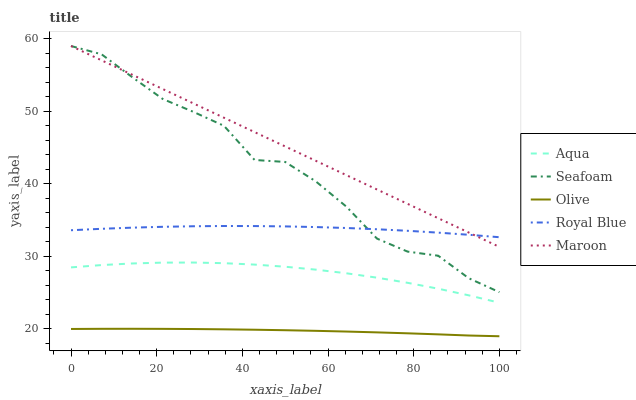Does Olive have the minimum area under the curve?
Answer yes or no. Yes. Does Maroon have the maximum area under the curve?
Answer yes or no. Yes. Does Royal Blue have the minimum area under the curve?
Answer yes or no. No. Does Royal Blue have the maximum area under the curve?
Answer yes or no. No. Is Maroon the smoothest?
Answer yes or no. Yes. Is Seafoam the roughest?
Answer yes or no. Yes. Is Royal Blue the smoothest?
Answer yes or no. No. Is Royal Blue the roughest?
Answer yes or no. No. Does Olive have the lowest value?
Answer yes or no. Yes. Does Aqua have the lowest value?
Answer yes or no. No. Does Maroon have the highest value?
Answer yes or no. Yes. Does Royal Blue have the highest value?
Answer yes or no. No. Is Aqua less than Royal Blue?
Answer yes or no. Yes. Is Seafoam greater than Olive?
Answer yes or no. Yes. Does Royal Blue intersect Maroon?
Answer yes or no. Yes. Is Royal Blue less than Maroon?
Answer yes or no. No. Is Royal Blue greater than Maroon?
Answer yes or no. No. Does Aqua intersect Royal Blue?
Answer yes or no. No. 